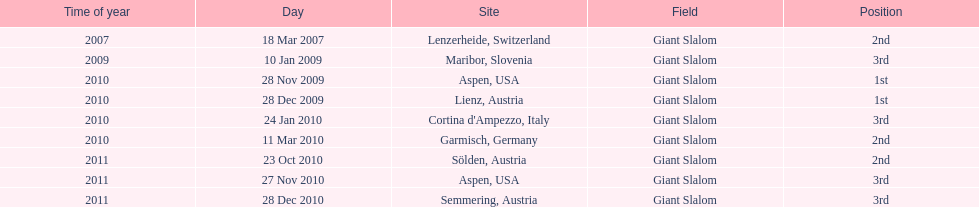How many races were in 2010? 5. Can you give me this table as a dict? {'header': ['Time of year', 'Day', 'Site', 'Field', 'Position'], 'rows': [['2007', '18 Mar 2007', 'Lenzerheide, Switzerland', 'Giant Slalom', '2nd'], ['2009', '10 Jan 2009', 'Maribor, Slovenia', 'Giant Slalom', '3rd'], ['2010', '28 Nov 2009', 'Aspen, USA', 'Giant Slalom', '1st'], ['2010', '28 Dec 2009', 'Lienz, Austria', 'Giant Slalom', '1st'], ['2010', '24 Jan 2010', "Cortina d'Ampezzo, Italy", 'Giant Slalom', '3rd'], ['2010', '11 Mar 2010', 'Garmisch, Germany', 'Giant Slalom', '2nd'], ['2011', '23 Oct 2010', 'Sölden, Austria', 'Giant Slalom', '2nd'], ['2011', '27 Nov 2010', 'Aspen, USA', 'Giant Slalom', '3rd'], ['2011', '28 Dec 2010', 'Semmering, Austria', 'Giant Slalom', '3rd']]} 